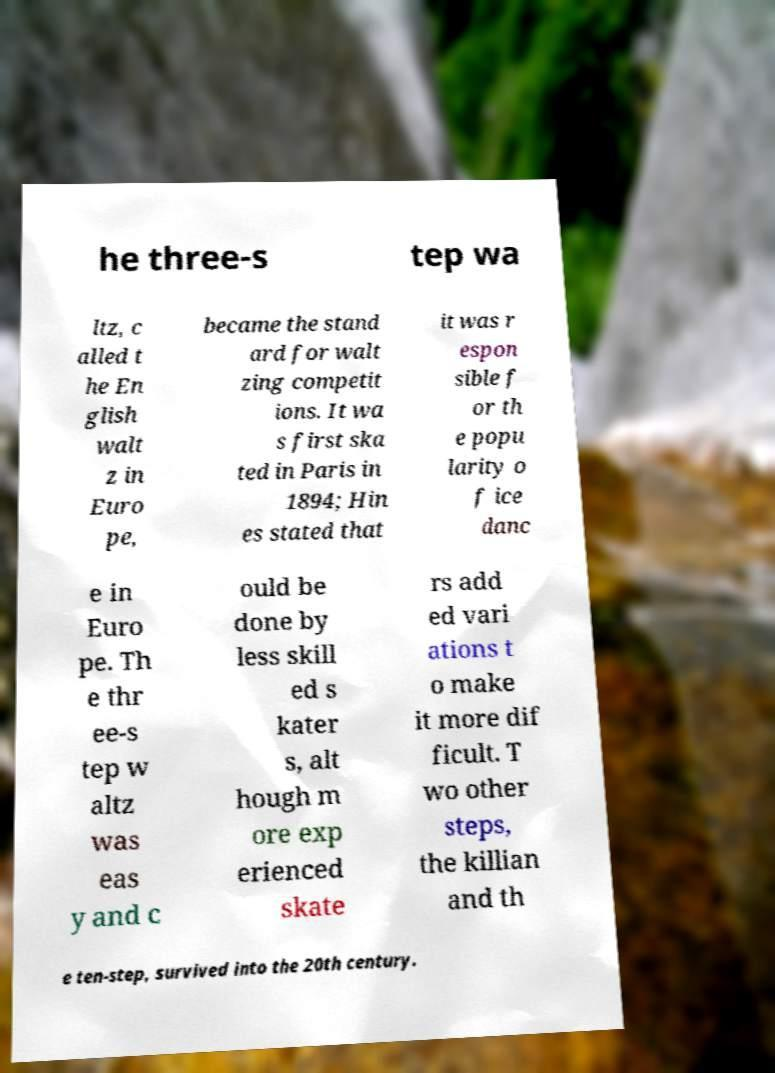Please identify and transcribe the text found in this image. he three-s tep wa ltz, c alled t he En glish walt z in Euro pe, became the stand ard for walt zing competit ions. It wa s first ska ted in Paris in 1894; Hin es stated that it was r espon sible f or th e popu larity o f ice danc e in Euro pe. Th e thr ee-s tep w altz was eas y and c ould be done by less skill ed s kater s, alt hough m ore exp erienced skate rs add ed vari ations t o make it more dif ficult. T wo other steps, the killian and th e ten-step, survived into the 20th century. 